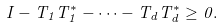Convert formula to latex. <formula><loc_0><loc_0><loc_500><loc_500>I - T _ { 1 } T _ { 1 } ^ { * } - \cdots - T _ { d } T _ { d } ^ { * } \geq 0 .</formula> 